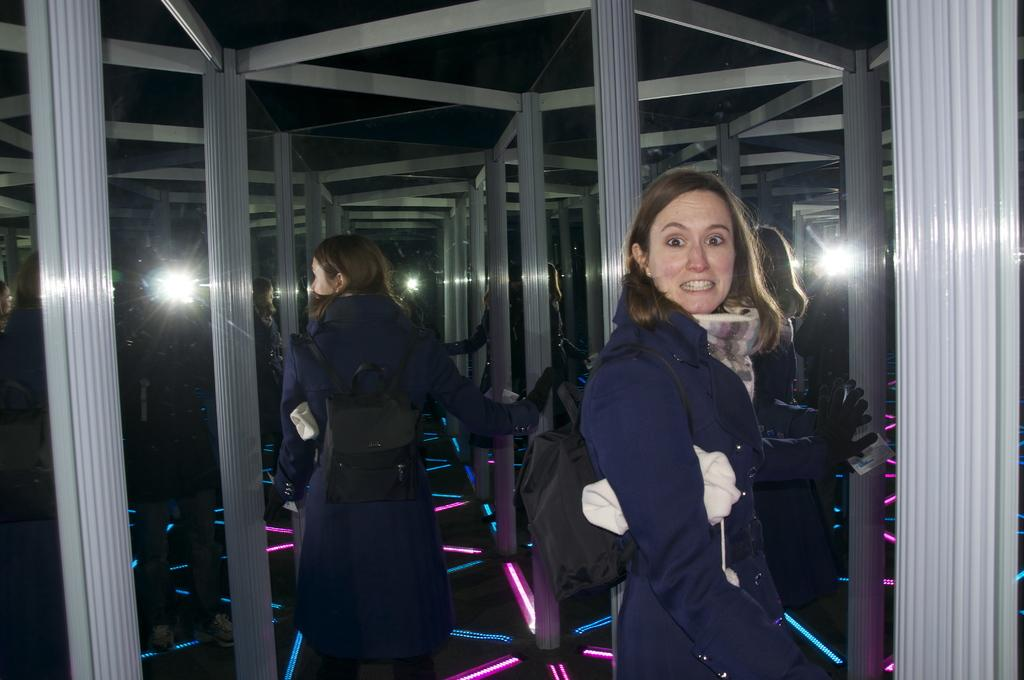What is the main subject in the foreground of the image? There is a person in the foreground of the image. What objects can be seen in the background of the image? There are mirrors in the background of the image. What type of chicken is being celebrated during the holiday in the image? There is no chicken or holiday present in the image; it only features a person and mirrors in the background. 